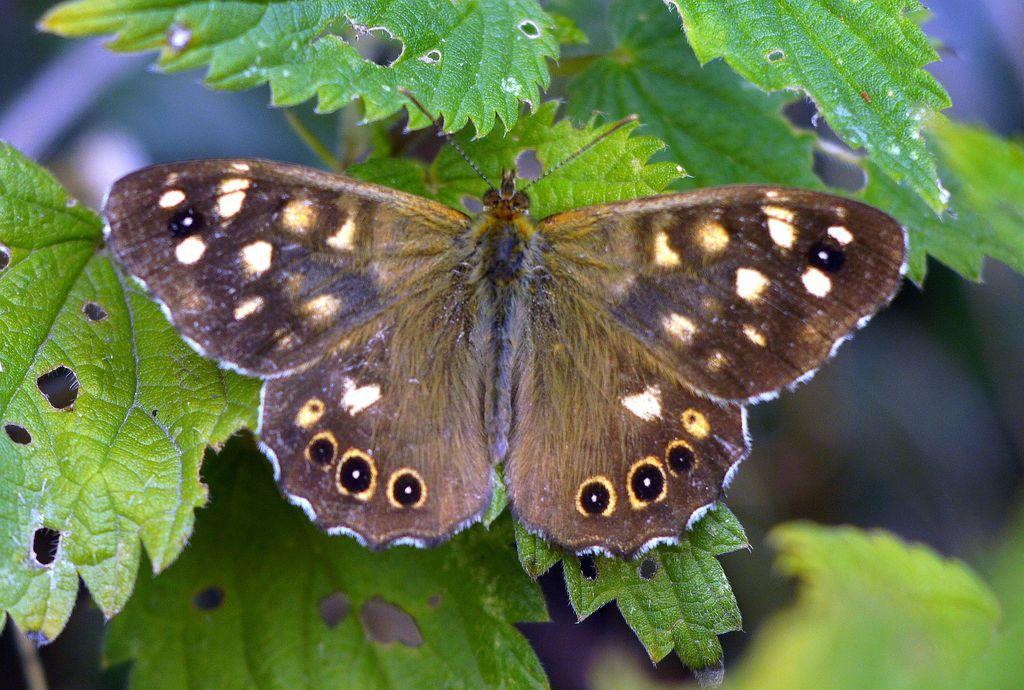What is the main subject of the image? There is a butterfly in the center of the image. What can be seen in the background of the image? There are leaves in the background of the image. What type of beast can be seen pushing the corn in the image? There is no beast or corn present in the image; it features a butterfly and leaves. 